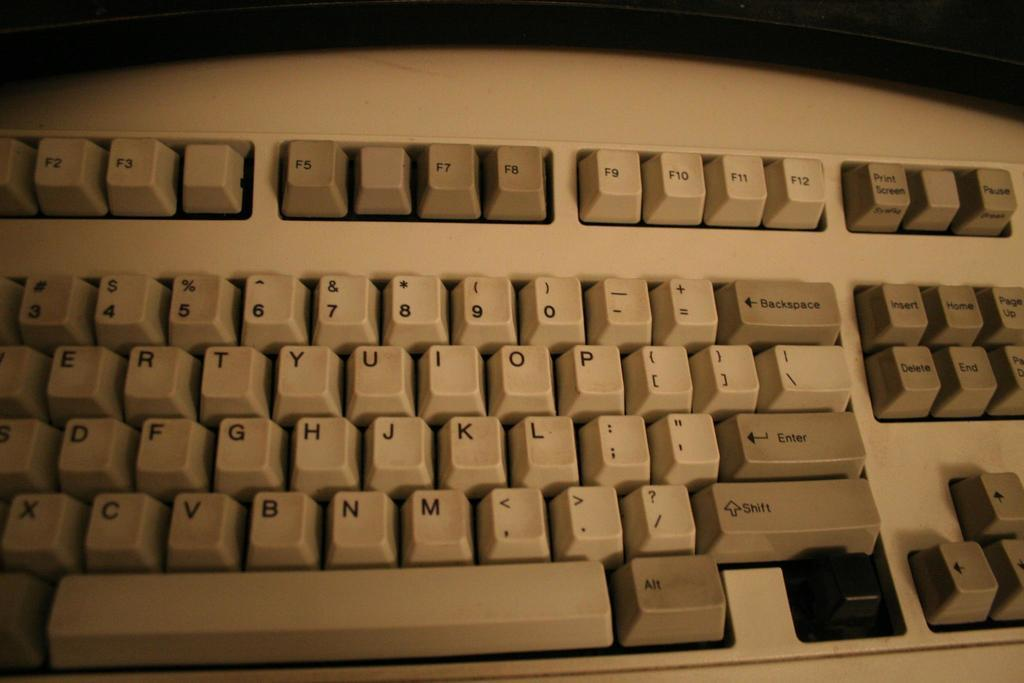<image>
Present a compact description of the photo's key features. An old keyboard is missing the key below the Shift key. 